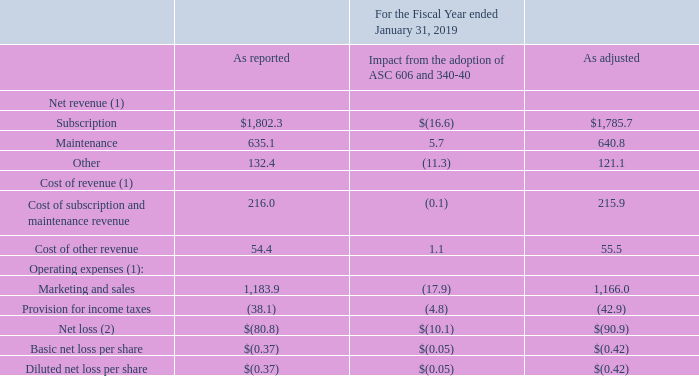Quantitative effect of ASC Topics 606 and 340-40 adoption
(1) While not shown here, gross margin, loss from operations, and loss before income taxes have consequently been affected as a result of the net effect of the adjustments noted above.
(2) The impact on the Consolidated Statements of Comprehensive Loss is limited to the net effects of the impacts noted above on the Consolidated Statements of Operations, specifically on the line item "Net loss."
What have been affected as a result of the net effect of the adjustments? Gross margin, loss from operations, and loss before income taxes have consequently been affected as a result of the net effect of the adjustments noted above. What was the adjusted cost of subscription and maintenance revenue for fiscal year 2019? 215.9. What were the reported marketing and sales expenses? 1,183.9. What was the adjustment amount as a % of subscription net revenue?
Answer scale should be: percent. (16.6/1,802.3)
Answer: 0.92. What is other reported revenue as a % of total reported net revenue?
Answer scale should be: percent. (132.4/(1,802.3+635.1+132.4))
Answer: 5.15. How much is total cost of revenue as reported?
Answer scale should be: million. 216+54.4 
Answer: 270.4. 